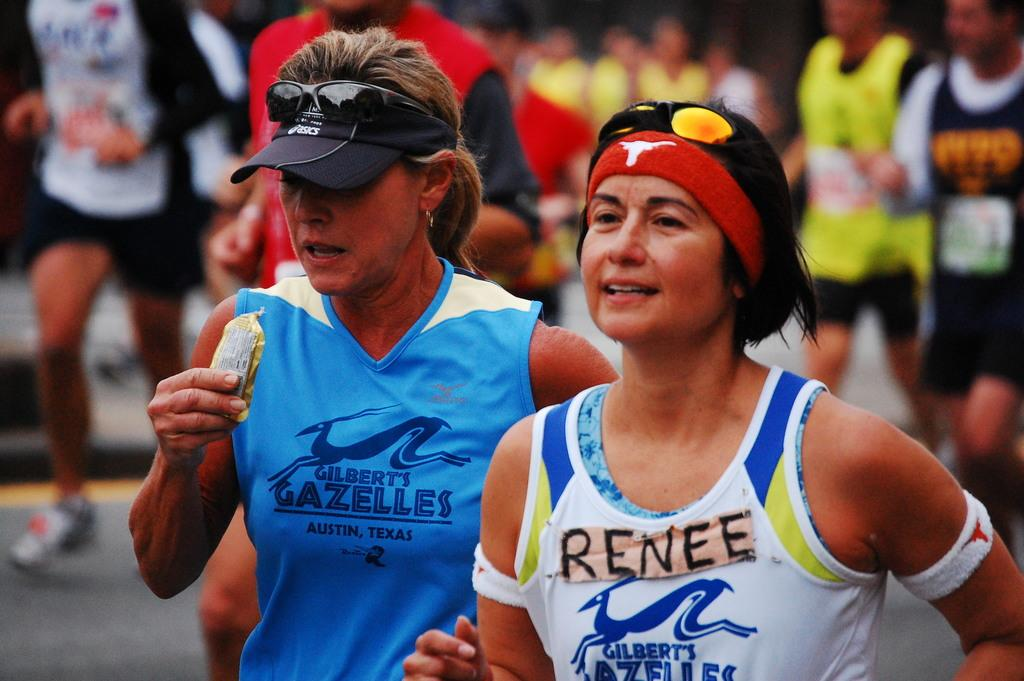<image>
Write a terse but informative summary of the picture. Renee and her running mates are wearing Gilbert's Gazelles top 